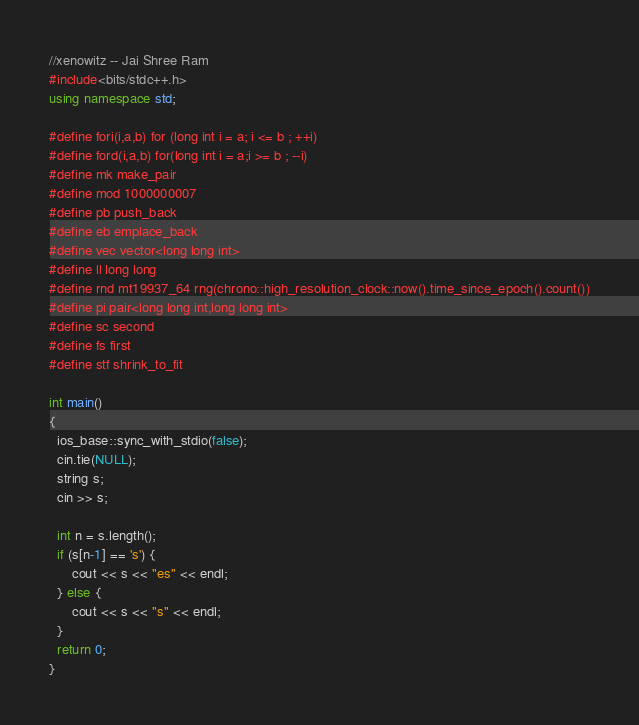Convert code to text. <code><loc_0><loc_0><loc_500><loc_500><_C++_>//xenowitz -- Jai Shree Ram
#include<bits/stdc++.h>
using namespace std;

#define fori(i,a,b) for (long int i = a; i <= b ; ++i)
#define ford(i,a,b) for(long int i = a;i >= b ; --i)
#define mk make_pair
#define mod 1000000007
#define pb push_back
#define eb emplace_back
#define vec vector<long long int>
#define ll long long
#define rnd mt19937_64 rng(chrono::high_resolution_clock::now().time_since_epoch().count())
#define pi pair<long long int,long long int>
#define sc second
#define fs first
#define stf shrink_to_fit

int main()
{
  ios_base::sync_with_stdio(false);
  cin.tie(NULL);
  string s;
  cin >> s;

  int n = s.length();
  if (s[n-1] == 's') {
      cout << s << "es" << endl;
  } else {
      cout << s << "s" << endl;
  }
  return 0;
}
</code> 